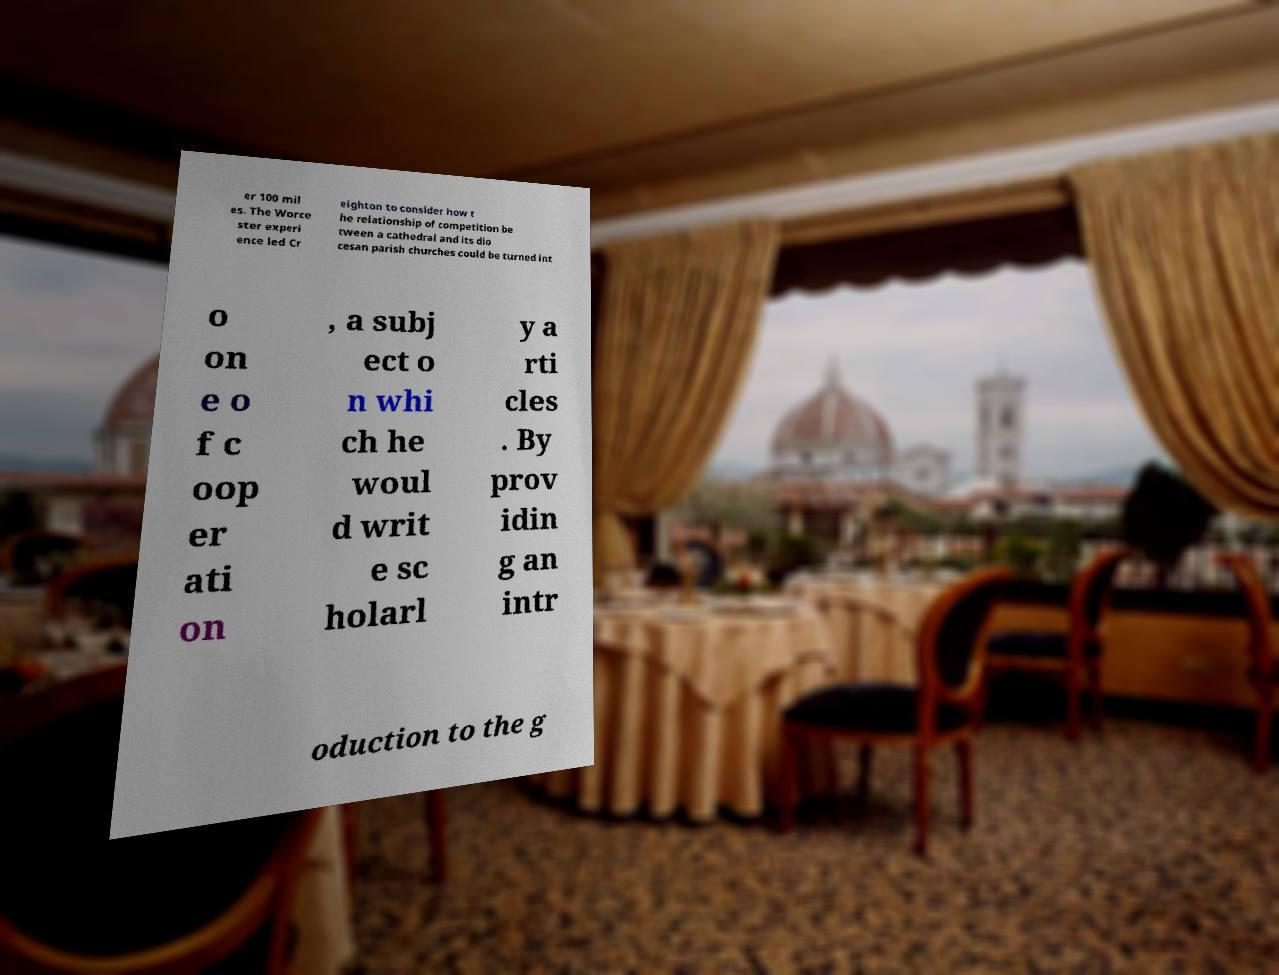Could you extract and type out the text from this image? er 100 mil es. The Worce ster experi ence led Cr eighton to consider how t he relationship of competition be tween a cathedral and its dio cesan parish churches could be turned int o on e o f c oop er ati on , a subj ect o n whi ch he woul d writ e sc holarl y a rti cles . By prov idin g an intr oduction to the g 